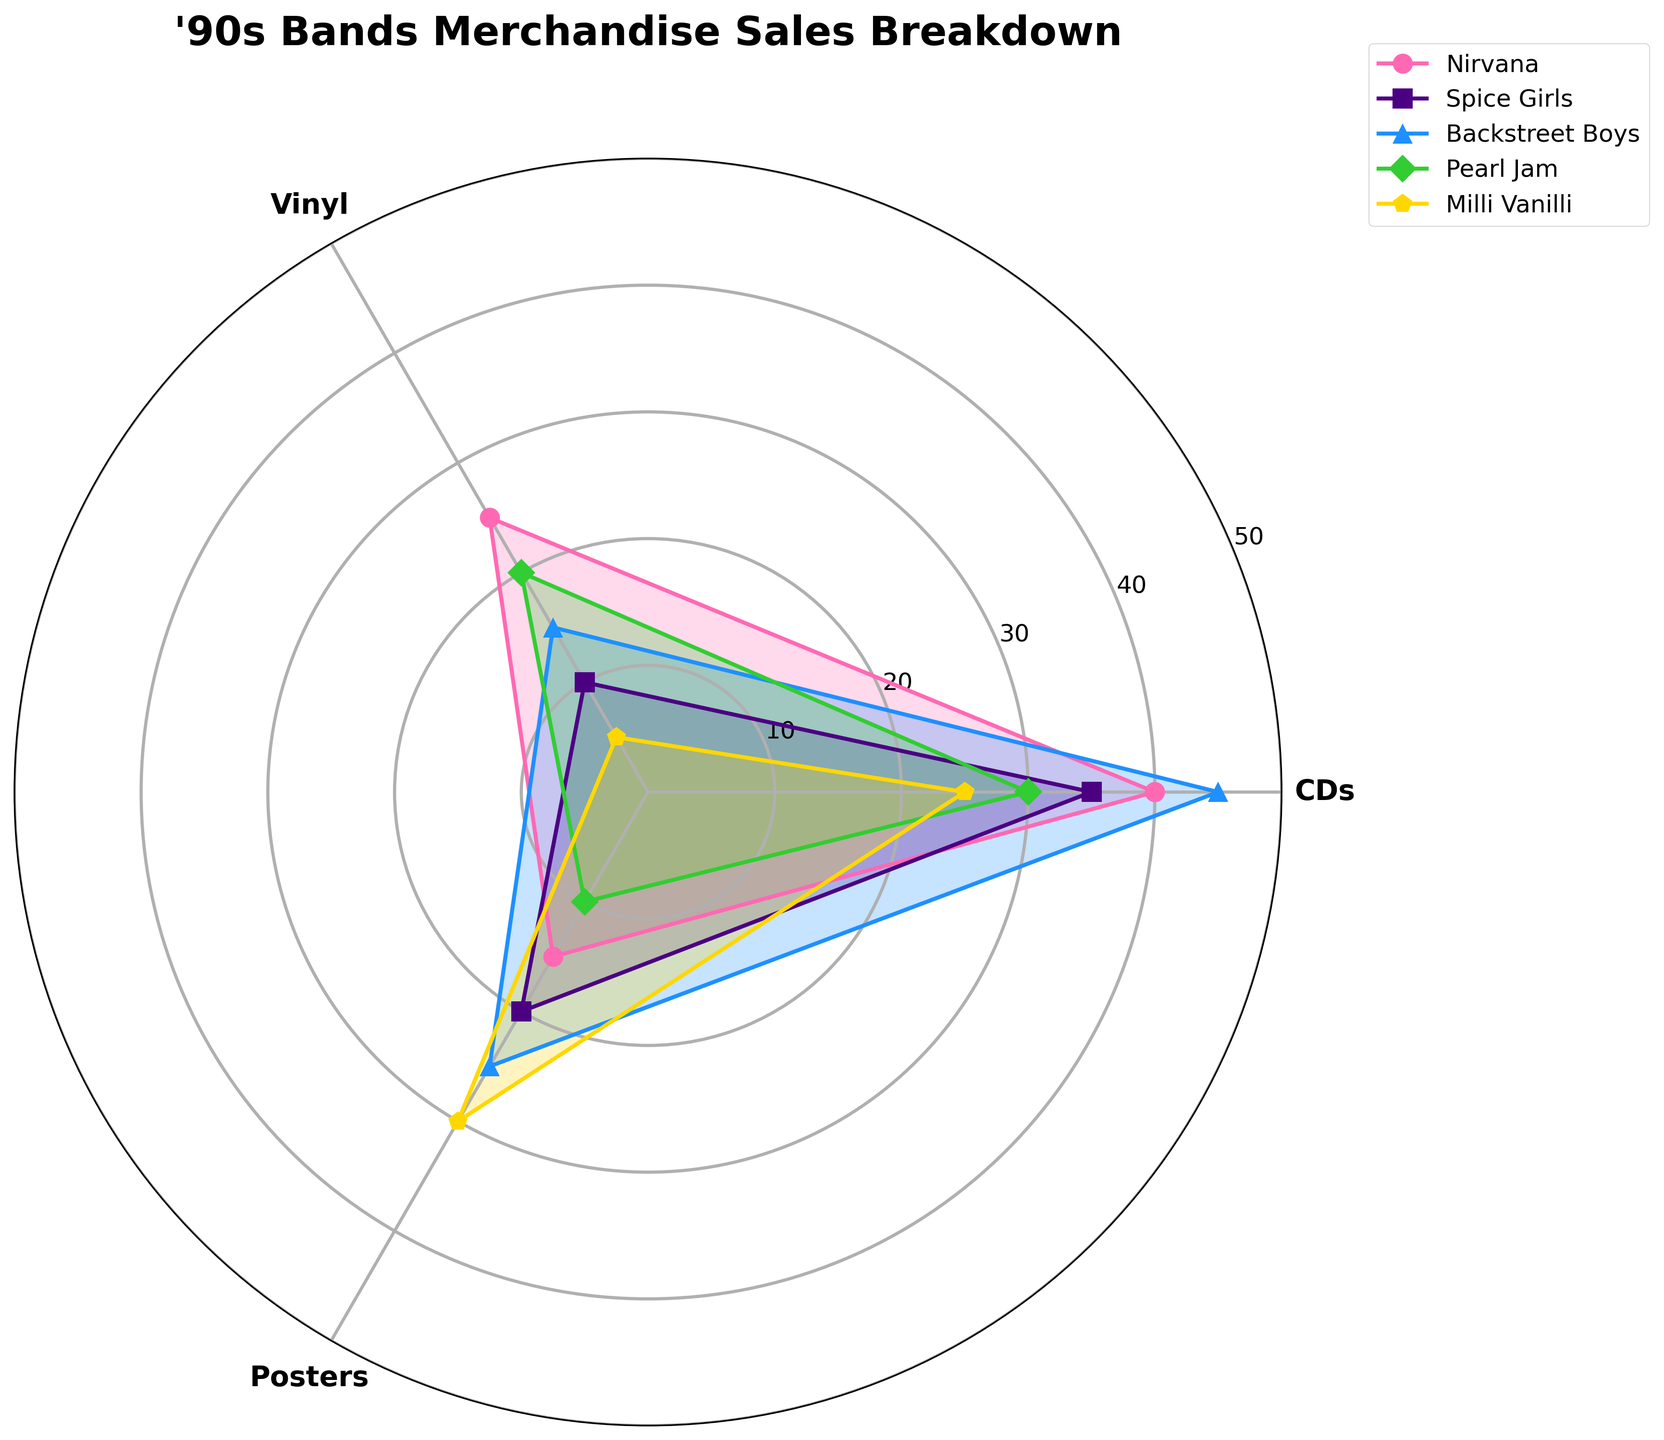What's the title of the chart? The title is usually displayed at the top of the chart. In this case, it would clearly read "'90s Bands Merchandise Sales Breakdown".
Answer: '90s Bands Merchandise Sales Breakdown Which band has the highest CD sales? By looking at the length of the lines extending from the center of the polar chart towards the CD point, we can see the Backstreet Boys have the longest line, indicating the highest CD sales.
Answer: Backstreet Boys What is the total merchandise value sold by Nirvana? Add up the values of CDs, vinyl, and posters for Nirvana from the chart: 40 (CDs) + 25 (vinyl) + 15 (posters) = 80.
Answer: 80 How much higher are the poster sales of Milli Vanilli compared to Nirvana? Look at the poster values for both bands on the chart: Milli Vanilli has 30 and Nirvana has 15. The difference is 30 - 15 = 15.
Answer: 15 Which band has the lowest vinyl sales? Identify the smallest segment extending from the center to the vinyl point on the chart. Milli Vanilli, with only 5 units, has the lowest vinyl sales.
Answer: Milli Vanilli What is the average sales value of posters for all bands? Sum the poster sales values for all bands and divide by the number of bands: (15 + 20 + 25 + 10 + 30) / 5 = 100 / 5 = 20.
Answer: 20 Which band's merch type has the same value for CDs and posters? Compare the length of the CD and poster lines for each band. Every band seems to have different values except for Milli Vanilli, where CDs and posters both appear at 25 and 30 respectively. Since no exact same value, this query is invalid.
Answer: N/A: There is no band with exactly same CD and poster values Which merch type has the most varied sales figures across all bands? Vinyl sales appear to have the most variation, with values ranging from a low of 5 units to a high of 25 units across the different bands.
Answer: Vinyl If you were to average CD sales for Spice Girls and Backstreet Boys, what would it be? Add the CD sales of Spice Girls (35) and Backstreet Boys (45) and divide by 2: (35 + 45) / 2 = 80 / 2 = 40.
Answer: 40 Compare the total sales values of CDs and posters for Pearl Jam. Which is higher and by how much? CDs have 30 units and posters have 10 units for Pearl Jam. The difference is 30 - 10 = 20, with CDs being higher.
Answer: CDs by 20 